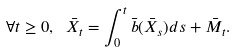Convert formula to latex. <formula><loc_0><loc_0><loc_500><loc_500>\forall t \geq 0 , \ \bar { X } _ { t } = \int _ { 0 } ^ { t } \bar { b } ( \bar { X } _ { s } ) d s + \bar { M } _ { t } .</formula> 